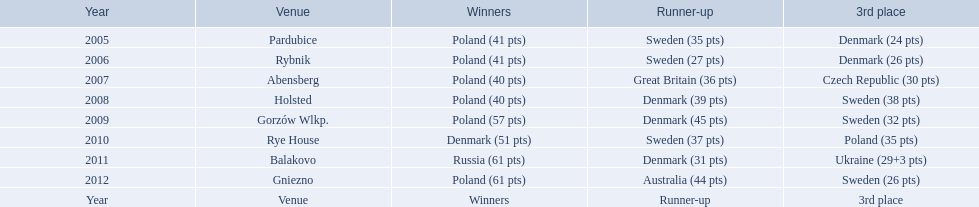Did the 2010 championship see holland as the victor? Rye House. If they weren't, which team won and where did holland place? 3rd place. 